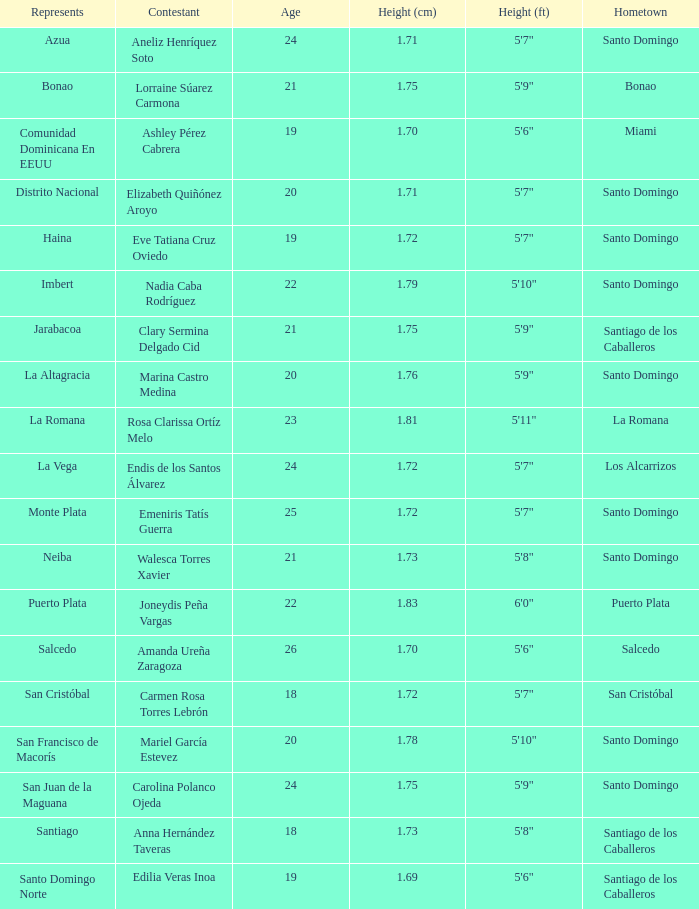76 cm La Altagracia. 